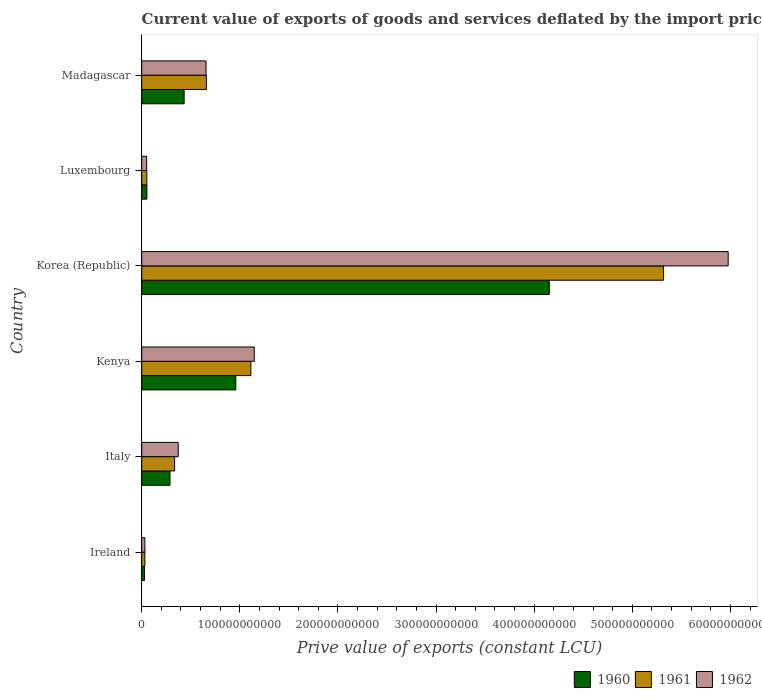Are the number of bars per tick equal to the number of legend labels?
Keep it short and to the point. Yes. How many bars are there on the 1st tick from the top?
Your response must be concise. 3. What is the label of the 1st group of bars from the top?
Provide a short and direct response. Madagascar. In how many cases, is the number of bars for a given country not equal to the number of legend labels?
Your answer should be very brief. 0. What is the prive value of exports in 1962 in Ireland?
Ensure brevity in your answer.  3.23e+09. Across all countries, what is the maximum prive value of exports in 1961?
Make the answer very short. 5.32e+11. Across all countries, what is the minimum prive value of exports in 1962?
Offer a very short reply. 3.23e+09. In which country was the prive value of exports in 1962 maximum?
Your response must be concise. Korea (Republic). In which country was the prive value of exports in 1962 minimum?
Offer a very short reply. Ireland. What is the total prive value of exports in 1960 in the graph?
Provide a short and direct response. 5.91e+11. What is the difference between the prive value of exports in 1960 in Ireland and that in Korea (Republic)?
Your response must be concise. -4.13e+11. What is the difference between the prive value of exports in 1960 in Italy and the prive value of exports in 1962 in Madagascar?
Ensure brevity in your answer.  -3.67e+1. What is the average prive value of exports in 1962 per country?
Make the answer very short. 1.37e+11. What is the difference between the prive value of exports in 1962 and prive value of exports in 1961 in Kenya?
Ensure brevity in your answer.  3.47e+09. What is the ratio of the prive value of exports in 1962 in Ireland to that in Italy?
Provide a short and direct response. 0.09. What is the difference between the highest and the second highest prive value of exports in 1960?
Keep it short and to the point. 3.19e+11. What is the difference between the highest and the lowest prive value of exports in 1961?
Provide a short and direct response. 5.29e+11. In how many countries, is the prive value of exports in 1961 greater than the average prive value of exports in 1961 taken over all countries?
Your answer should be very brief. 1. Is the sum of the prive value of exports in 1962 in Kenya and Luxembourg greater than the maximum prive value of exports in 1960 across all countries?
Ensure brevity in your answer.  No. What does the 2nd bar from the top in Ireland represents?
Keep it short and to the point. 1961. What does the 2nd bar from the bottom in Kenya represents?
Keep it short and to the point. 1961. How many countries are there in the graph?
Offer a terse response. 6. What is the difference between two consecutive major ticks on the X-axis?
Offer a terse response. 1.00e+11. Does the graph contain any zero values?
Provide a succinct answer. No. Where does the legend appear in the graph?
Ensure brevity in your answer.  Bottom right. How many legend labels are there?
Your answer should be compact. 3. What is the title of the graph?
Keep it short and to the point. Current value of exports of goods and services deflated by the import price index. Does "1979" appear as one of the legend labels in the graph?
Provide a succinct answer. No. What is the label or title of the X-axis?
Your response must be concise. Prive value of exports (constant LCU). What is the label or title of the Y-axis?
Your response must be concise. Country. What is the Prive value of exports (constant LCU) of 1960 in Ireland?
Keep it short and to the point. 2.78e+09. What is the Prive value of exports (constant LCU) of 1961 in Ireland?
Provide a short and direct response. 3.22e+09. What is the Prive value of exports (constant LCU) in 1962 in Ireland?
Your response must be concise. 3.23e+09. What is the Prive value of exports (constant LCU) of 1960 in Italy?
Give a very brief answer. 2.88e+1. What is the Prive value of exports (constant LCU) of 1961 in Italy?
Keep it short and to the point. 3.35e+1. What is the Prive value of exports (constant LCU) in 1962 in Italy?
Offer a very short reply. 3.72e+1. What is the Prive value of exports (constant LCU) of 1960 in Kenya?
Keep it short and to the point. 9.59e+1. What is the Prive value of exports (constant LCU) in 1961 in Kenya?
Keep it short and to the point. 1.11e+11. What is the Prive value of exports (constant LCU) of 1962 in Kenya?
Give a very brief answer. 1.15e+11. What is the Prive value of exports (constant LCU) of 1960 in Korea (Republic)?
Offer a terse response. 4.15e+11. What is the Prive value of exports (constant LCU) of 1961 in Korea (Republic)?
Offer a very short reply. 5.32e+11. What is the Prive value of exports (constant LCU) of 1962 in Korea (Republic)?
Make the answer very short. 5.98e+11. What is the Prive value of exports (constant LCU) of 1960 in Luxembourg?
Keep it short and to the point. 5.28e+09. What is the Prive value of exports (constant LCU) of 1961 in Luxembourg?
Keep it short and to the point. 5.22e+09. What is the Prive value of exports (constant LCU) of 1962 in Luxembourg?
Offer a very short reply. 5.02e+09. What is the Prive value of exports (constant LCU) of 1960 in Madagascar?
Keep it short and to the point. 4.32e+1. What is the Prive value of exports (constant LCU) in 1961 in Madagascar?
Your answer should be very brief. 6.59e+1. What is the Prive value of exports (constant LCU) of 1962 in Madagascar?
Offer a very short reply. 6.55e+1. Across all countries, what is the maximum Prive value of exports (constant LCU) of 1960?
Offer a terse response. 4.15e+11. Across all countries, what is the maximum Prive value of exports (constant LCU) in 1961?
Give a very brief answer. 5.32e+11. Across all countries, what is the maximum Prive value of exports (constant LCU) of 1962?
Provide a succinct answer. 5.98e+11. Across all countries, what is the minimum Prive value of exports (constant LCU) in 1960?
Your answer should be very brief. 2.78e+09. Across all countries, what is the minimum Prive value of exports (constant LCU) in 1961?
Provide a short and direct response. 3.22e+09. Across all countries, what is the minimum Prive value of exports (constant LCU) in 1962?
Your response must be concise. 3.23e+09. What is the total Prive value of exports (constant LCU) in 1960 in the graph?
Ensure brevity in your answer.  5.91e+11. What is the total Prive value of exports (constant LCU) of 1961 in the graph?
Provide a succinct answer. 7.51e+11. What is the total Prive value of exports (constant LCU) in 1962 in the graph?
Offer a very short reply. 8.23e+11. What is the difference between the Prive value of exports (constant LCU) in 1960 in Ireland and that in Italy?
Your answer should be very brief. -2.60e+1. What is the difference between the Prive value of exports (constant LCU) in 1961 in Ireland and that in Italy?
Make the answer very short. -3.03e+1. What is the difference between the Prive value of exports (constant LCU) of 1962 in Ireland and that in Italy?
Make the answer very short. -3.40e+1. What is the difference between the Prive value of exports (constant LCU) in 1960 in Ireland and that in Kenya?
Provide a succinct answer. -9.31e+1. What is the difference between the Prive value of exports (constant LCU) in 1961 in Ireland and that in Kenya?
Keep it short and to the point. -1.08e+11. What is the difference between the Prive value of exports (constant LCU) in 1962 in Ireland and that in Kenya?
Give a very brief answer. -1.11e+11. What is the difference between the Prive value of exports (constant LCU) of 1960 in Ireland and that in Korea (Republic)?
Provide a succinct answer. -4.13e+11. What is the difference between the Prive value of exports (constant LCU) in 1961 in Ireland and that in Korea (Republic)?
Your answer should be compact. -5.29e+11. What is the difference between the Prive value of exports (constant LCU) in 1962 in Ireland and that in Korea (Republic)?
Provide a short and direct response. -5.94e+11. What is the difference between the Prive value of exports (constant LCU) of 1960 in Ireland and that in Luxembourg?
Offer a very short reply. -2.50e+09. What is the difference between the Prive value of exports (constant LCU) of 1961 in Ireland and that in Luxembourg?
Keep it short and to the point. -2.01e+09. What is the difference between the Prive value of exports (constant LCU) of 1962 in Ireland and that in Luxembourg?
Ensure brevity in your answer.  -1.79e+09. What is the difference between the Prive value of exports (constant LCU) in 1960 in Ireland and that in Madagascar?
Offer a very short reply. -4.04e+1. What is the difference between the Prive value of exports (constant LCU) in 1961 in Ireland and that in Madagascar?
Provide a succinct answer. -6.27e+1. What is the difference between the Prive value of exports (constant LCU) of 1962 in Ireland and that in Madagascar?
Make the answer very short. -6.23e+1. What is the difference between the Prive value of exports (constant LCU) in 1960 in Italy and that in Kenya?
Keep it short and to the point. -6.71e+1. What is the difference between the Prive value of exports (constant LCU) of 1961 in Italy and that in Kenya?
Ensure brevity in your answer.  -7.77e+1. What is the difference between the Prive value of exports (constant LCU) of 1962 in Italy and that in Kenya?
Offer a terse response. -7.75e+1. What is the difference between the Prive value of exports (constant LCU) in 1960 in Italy and that in Korea (Republic)?
Offer a terse response. -3.87e+11. What is the difference between the Prive value of exports (constant LCU) in 1961 in Italy and that in Korea (Republic)?
Provide a short and direct response. -4.98e+11. What is the difference between the Prive value of exports (constant LCU) of 1962 in Italy and that in Korea (Republic)?
Keep it short and to the point. -5.60e+11. What is the difference between the Prive value of exports (constant LCU) of 1960 in Italy and that in Luxembourg?
Keep it short and to the point. 2.35e+1. What is the difference between the Prive value of exports (constant LCU) in 1961 in Italy and that in Luxembourg?
Ensure brevity in your answer.  2.83e+1. What is the difference between the Prive value of exports (constant LCU) of 1962 in Italy and that in Luxembourg?
Keep it short and to the point. 3.22e+1. What is the difference between the Prive value of exports (constant LCU) in 1960 in Italy and that in Madagascar?
Make the answer very short. -1.44e+1. What is the difference between the Prive value of exports (constant LCU) of 1961 in Italy and that in Madagascar?
Ensure brevity in your answer.  -3.24e+1. What is the difference between the Prive value of exports (constant LCU) in 1962 in Italy and that in Madagascar?
Provide a short and direct response. -2.84e+1. What is the difference between the Prive value of exports (constant LCU) in 1960 in Kenya and that in Korea (Republic)?
Give a very brief answer. -3.19e+11. What is the difference between the Prive value of exports (constant LCU) in 1961 in Kenya and that in Korea (Republic)?
Your answer should be compact. -4.21e+11. What is the difference between the Prive value of exports (constant LCU) in 1962 in Kenya and that in Korea (Republic)?
Your answer should be very brief. -4.83e+11. What is the difference between the Prive value of exports (constant LCU) of 1960 in Kenya and that in Luxembourg?
Provide a short and direct response. 9.06e+1. What is the difference between the Prive value of exports (constant LCU) of 1961 in Kenya and that in Luxembourg?
Your response must be concise. 1.06e+11. What is the difference between the Prive value of exports (constant LCU) in 1962 in Kenya and that in Luxembourg?
Make the answer very short. 1.10e+11. What is the difference between the Prive value of exports (constant LCU) of 1960 in Kenya and that in Madagascar?
Your answer should be compact. 5.27e+1. What is the difference between the Prive value of exports (constant LCU) in 1961 in Kenya and that in Madagascar?
Give a very brief answer. 4.53e+1. What is the difference between the Prive value of exports (constant LCU) of 1962 in Kenya and that in Madagascar?
Your response must be concise. 4.92e+1. What is the difference between the Prive value of exports (constant LCU) in 1960 in Korea (Republic) and that in Luxembourg?
Offer a terse response. 4.10e+11. What is the difference between the Prive value of exports (constant LCU) in 1961 in Korea (Republic) and that in Luxembourg?
Your answer should be very brief. 5.27e+11. What is the difference between the Prive value of exports (constant LCU) of 1962 in Korea (Republic) and that in Luxembourg?
Keep it short and to the point. 5.93e+11. What is the difference between the Prive value of exports (constant LCU) of 1960 in Korea (Republic) and that in Madagascar?
Your response must be concise. 3.72e+11. What is the difference between the Prive value of exports (constant LCU) of 1961 in Korea (Republic) and that in Madagascar?
Your answer should be very brief. 4.66e+11. What is the difference between the Prive value of exports (constant LCU) of 1962 in Korea (Republic) and that in Madagascar?
Offer a very short reply. 5.32e+11. What is the difference between the Prive value of exports (constant LCU) in 1960 in Luxembourg and that in Madagascar?
Give a very brief answer. -3.79e+1. What is the difference between the Prive value of exports (constant LCU) of 1961 in Luxembourg and that in Madagascar?
Your response must be concise. -6.07e+1. What is the difference between the Prive value of exports (constant LCU) in 1962 in Luxembourg and that in Madagascar?
Give a very brief answer. -6.05e+1. What is the difference between the Prive value of exports (constant LCU) of 1960 in Ireland and the Prive value of exports (constant LCU) of 1961 in Italy?
Your response must be concise. -3.08e+1. What is the difference between the Prive value of exports (constant LCU) in 1960 in Ireland and the Prive value of exports (constant LCU) in 1962 in Italy?
Your answer should be compact. -3.44e+1. What is the difference between the Prive value of exports (constant LCU) of 1961 in Ireland and the Prive value of exports (constant LCU) of 1962 in Italy?
Make the answer very short. -3.40e+1. What is the difference between the Prive value of exports (constant LCU) of 1960 in Ireland and the Prive value of exports (constant LCU) of 1961 in Kenya?
Keep it short and to the point. -1.08e+11. What is the difference between the Prive value of exports (constant LCU) of 1960 in Ireland and the Prive value of exports (constant LCU) of 1962 in Kenya?
Your answer should be compact. -1.12e+11. What is the difference between the Prive value of exports (constant LCU) of 1961 in Ireland and the Prive value of exports (constant LCU) of 1962 in Kenya?
Offer a terse response. -1.11e+11. What is the difference between the Prive value of exports (constant LCU) of 1960 in Ireland and the Prive value of exports (constant LCU) of 1961 in Korea (Republic)?
Ensure brevity in your answer.  -5.29e+11. What is the difference between the Prive value of exports (constant LCU) in 1960 in Ireland and the Prive value of exports (constant LCU) in 1962 in Korea (Republic)?
Your answer should be very brief. -5.95e+11. What is the difference between the Prive value of exports (constant LCU) in 1961 in Ireland and the Prive value of exports (constant LCU) in 1962 in Korea (Republic)?
Offer a terse response. -5.94e+11. What is the difference between the Prive value of exports (constant LCU) of 1960 in Ireland and the Prive value of exports (constant LCU) of 1961 in Luxembourg?
Offer a terse response. -2.45e+09. What is the difference between the Prive value of exports (constant LCU) in 1960 in Ireland and the Prive value of exports (constant LCU) in 1962 in Luxembourg?
Ensure brevity in your answer.  -2.24e+09. What is the difference between the Prive value of exports (constant LCU) in 1961 in Ireland and the Prive value of exports (constant LCU) in 1962 in Luxembourg?
Keep it short and to the point. -1.80e+09. What is the difference between the Prive value of exports (constant LCU) of 1960 in Ireland and the Prive value of exports (constant LCU) of 1961 in Madagascar?
Your response must be concise. -6.31e+1. What is the difference between the Prive value of exports (constant LCU) in 1960 in Ireland and the Prive value of exports (constant LCU) in 1962 in Madagascar?
Keep it short and to the point. -6.28e+1. What is the difference between the Prive value of exports (constant LCU) in 1961 in Ireland and the Prive value of exports (constant LCU) in 1962 in Madagascar?
Your answer should be compact. -6.23e+1. What is the difference between the Prive value of exports (constant LCU) of 1960 in Italy and the Prive value of exports (constant LCU) of 1961 in Kenya?
Your answer should be very brief. -8.24e+1. What is the difference between the Prive value of exports (constant LCU) in 1960 in Italy and the Prive value of exports (constant LCU) in 1962 in Kenya?
Provide a succinct answer. -8.59e+1. What is the difference between the Prive value of exports (constant LCU) in 1961 in Italy and the Prive value of exports (constant LCU) in 1962 in Kenya?
Keep it short and to the point. -8.12e+1. What is the difference between the Prive value of exports (constant LCU) of 1960 in Italy and the Prive value of exports (constant LCU) of 1961 in Korea (Republic)?
Offer a very short reply. -5.03e+11. What is the difference between the Prive value of exports (constant LCU) in 1960 in Italy and the Prive value of exports (constant LCU) in 1962 in Korea (Republic)?
Your response must be concise. -5.69e+11. What is the difference between the Prive value of exports (constant LCU) of 1961 in Italy and the Prive value of exports (constant LCU) of 1962 in Korea (Republic)?
Your answer should be compact. -5.64e+11. What is the difference between the Prive value of exports (constant LCU) in 1960 in Italy and the Prive value of exports (constant LCU) in 1961 in Luxembourg?
Make the answer very short. 2.36e+1. What is the difference between the Prive value of exports (constant LCU) of 1960 in Italy and the Prive value of exports (constant LCU) of 1962 in Luxembourg?
Ensure brevity in your answer.  2.38e+1. What is the difference between the Prive value of exports (constant LCU) in 1961 in Italy and the Prive value of exports (constant LCU) in 1962 in Luxembourg?
Keep it short and to the point. 2.85e+1. What is the difference between the Prive value of exports (constant LCU) in 1960 in Italy and the Prive value of exports (constant LCU) in 1961 in Madagascar?
Your answer should be very brief. -3.71e+1. What is the difference between the Prive value of exports (constant LCU) of 1960 in Italy and the Prive value of exports (constant LCU) of 1962 in Madagascar?
Ensure brevity in your answer.  -3.67e+1. What is the difference between the Prive value of exports (constant LCU) of 1961 in Italy and the Prive value of exports (constant LCU) of 1962 in Madagascar?
Your answer should be very brief. -3.20e+1. What is the difference between the Prive value of exports (constant LCU) of 1960 in Kenya and the Prive value of exports (constant LCU) of 1961 in Korea (Republic)?
Ensure brevity in your answer.  -4.36e+11. What is the difference between the Prive value of exports (constant LCU) in 1960 in Kenya and the Prive value of exports (constant LCU) in 1962 in Korea (Republic)?
Your response must be concise. -5.02e+11. What is the difference between the Prive value of exports (constant LCU) in 1961 in Kenya and the Prive value of exports (constant LCU) in 1962 in Korea (Republic)?
Your answer should be compact. -4.86e+11. What is the difference between the Prive value of exports (constant LCU) in 1960 in Kenya and the Prive value of exports (constant LCU) in 1961 in Luxembourg?
Offer a very short reply. 9.07e+1. What is the difference between the Prive value of exports (constant LCU) of 1960 in Kenya and the Prive value of exports (constant LCU) of 1962 in Luxembourg?
Provide a succinct answer. 9.09e+1. What is the difference between the Prive value of exports (constant LCU) of 1961 in Kenya and the Prive value of exports (constant LCU) of 1962 in Luxembourg?
Provide a short and direct response. 1.06e+11. What is the difference between the Prive value of exports (constant LCU) in 1960 in Kenya and the Prive value of exports (constant LCU) in 1961 in Madagascar?
Your answer should be very brief. 3.00e+1. What is the difference between the Prive value of exports (constant LCU) in 1960 in Kenya and the Prive value of exports (constant LCU) in 1962 in Madagascar?
Give a very brief answer. 3.03e+1. What is the difference between the Prive value of exports (constant LCU) of 1961 in Kenya and the Prive value of exports (constant LCU) of 1962 in Madagascar?
Your answer should be compact. 4.57e+1. What is the difference between the Prive value of exports (constant LCU) of 1960 in Korea (Republic) and the Prive value of exports (constant LCU) of 1961 in Luxembourg?
Give a very brief answer. 4.10e+11. What is the difference between the Prive value of exports (constant LCU) of 1960 in Korea (Republic) and the Prive value of exports (constant LCU) of 1962 in Luxembourg?
Give a very brief answer. 4.10e+11. What is the difference between the Prive value of exports (constant LCU) in 1961 in Korea (Republic) and the Prive value of exports (constant LCU) in 1962 in Luxembourg?
Offer a very short reply. 5.27e+11. What is the difference between the Prive value of exports (constant LCU) in 1960 in Korea (Republic) and the Prive value of exports (constant LCU) in 1961 in Madagascar?
Give a very brief answer. 3.49e+11. What is the difference between the Prive value of exports (constant LCU) in 1960 in Korea (Republic) and the Prive value of exports (constant LCU) in 1962 in Madagascar?
Offer a very short reply. 3.50e+11. What is the difference between the Prive value of exports (constant LCU) of 1961 in Korea (Republic) and the Prive value of exports (constant LCU) of 1962 in Madagascar?
Your response must be concise. 4.66e+11. What is the difference between the Prive value of exports (constant LCU) of 1960 in Luxembourg and the Prive value of exports (constant LCU) of 1961 in Madagascar?
Ensure brevity in your answer.  -6.06e+1. What is the difference between the Prive value of exports (constant LCU) of 1960 in Luxembourg and the Prive value of exports (constant LCU) of 1962 in Madagascar?
Provide a succinct answer. -6.03e+1. What is the difference between the Prive value of exports (constant LCU) in 1961 in Luxembourg and the Prive value of exports (constant LCU) in 1962 in Madagascar?
Provide a succinct answer. -6.03e+1. What is the average Prive value of exports (constant LCU) in 1960 per country?
Ensure brevity in your answer.  9.86e+1. What is the average Prive value of exports (constant LCU) in 1961 per country?
Offer a very short reply. 1.25e+11. What is the average Prive value of exports (constant LCU) of 1962 per country?
Offer a terse response. 1.37e+11. What is the difference between the Prive value of exports (constant LCU) of 1960 and Prive value of exports (constant LCU) of 1961 in Ireland?
Provide a short and direct response. -4.39e+08. What is the difference between the Prive value of exports (constant LCU) of 1960 and Prive value of exports (constant LCU) of 1962 in Ireland?
Your response must be concise. -4.49e+08. What is the difference between the Prive value of exports (constant LCU) of 1961 and Prive value of exports (constant LCU) of 1962 in Ireland?
Provide a succinct answer. -9.94e+06. What is the difference between the Prive value of exports (constant LCU) of 1960 and Prive value of exports (constant LCU) of 1961 in Italy?
Your answer should be very brief. -4.73e+09. What is the difference between the Prive value of exports (constant LCU) of 1960 and Prive value of exports (constant LCU) of 1962 in Italy?
Your answer should be compact. -8.38e+09. What is the difference between the Prive value of exports (constant LCU) in 1961 and Prive value of exports (constant LCU) in 1962 in Italy?
Offer a terse response. -3.65e+09. What is the difference between the Prive value of exports (constant LCU) of 1960 and Prive value of exports (constant LCU) of 1961 in Kenya?
Offer a very short reply. -1.54e+1. What is the difference between the Prive value of exports (constant LCU) of 1960 and Prive value of exports (constant LCU) of 1962 in Kenya?
Your answer should be compact. -1.88e+1. What is the difference between the Prive value of exports (constant LCU) of 1961 and Prive value of exports (constant LCU) of 1962 in Kenya?
Offer a very short reply. -3.47e+09. What is the difference between the Prive value of exports (constant LCU) of 1960 and Prive value of exports (constant LCU) of 1961 in Korea (Republic)?
Provide a succinct answer. -1.16e+11. What is the difference between the Prive value of exports (constant LCU) of 1960 and Prive value of exports (constant LCU) of 1962 in Korea (Republic)?
Your answer should be compact. -1.82e+11. What is the difference between the Prive value of exports (constant LCU) of 1961 and Prive value of exports (constant LCU) of 1962 in Korea (Republic)?
Offer a very short reply. -6.59e+1. What is the difference between the Prive value of exports (constant LCU) in 1960 and Prive value of exports (constant LCU) in 1961 in Luxembourg?
Offer a very short reply. 5.55e+07. What is the difference between the Prive value of exports (constant LCU) in 1960 and Prive value of exports (constant LCU) in 1962 in Luxembourg?
Make the answer very short. 2.64e+08. What is the difference between the Prive value of exports (constant LCU) of 1961 and Prive value of exports (constant LCU) of 1962 in Luxembourg?
Your answer should be very brief. 2.08e+08. What is the difference between the Prive value of exports (constant LCU) of 1960 and Prive value of exports (constant LCU) of 1961 in Madagascar?
Your response must be concise. -2.27e+1. What is the difference between the Prive value of exports (constant LCU) in 1960 and Prive value of exports (constant LCU) in 1962 in Madagascar?
Your answer should be compact. -2.23e+1. What is the difference between the Prive value of exports (constant LCU) of 1961 and Prive value of exports (constant LCU) of 1962 in Madagascar?
Offer a terse response. 3.52e+08. What is the ratio of the Prive value of exports (constant LCU) in 1960 in Ireland to that in Italy?
Provide a succinct answer. 0.1. What is the ratio of the Prive value of exports (constant LCU) of 1961 in Ireland to that in Italy?
Give a very brief answer. 0.1. What is the ratio of the Prive value of exports (constant LCU) of 1962 in Ireland to that in Italy?
Keep it short and to the point. 0.09. What is the ratio of the Prive value of exports (constant LCU) in 1960 in Ireland to that in Kenya?
Offer a very short reply. 0.03. What is the ratio of the Prive value of exports (constant LCU) of 1961 in Ireland to that in Kenya?
Offer a very short reply. 0.03. What is the ratio of the Prive value of exports (constant LCU) in 1962 in Ireland to that in Kenya?
Your answer should be compact. 0.03. What is the ratio of the Prive value of exports (constant LCU) of 1960 in Ireland to that in Korea (Republic)?
Ensure brevity in your answer.  0.01. What is the ratio of the Prive value of exports (constant LCU) of 1961 in Ireland to that in Korea (Republic)?
Provide a short and direct response. 0.01. What is the ratio of the Prive value of exports (constant LCU) in 1962 in Ireland to that in Korea (Republic)?
Your answer should be compact. 0.01. What is the ratio of the Prive value of exports (constant LCU) in 1960 in Ireland to that in Luxembourg?
Make the answer very short. 0.53. What is the ratio of the Prive value of exports (constant LCU) of 1961 in Ireland to that in Luxembourg?
Keep it short and to the point. 0.62. What is the ratio of the Prive value of exports (constant LCU) of 1962 in Ireland to that in Luxembourg?
Keep it short and to the point. 0.64. What is the ratio of the Prive value of exports (constant LCU) of 1960 in Ireland to that in Madagascar?
Provide a short and direct response. 0.06. What is the ratio of the Prive value of exports (constant LCU) of 1961 in Ireland to that in Madagascar?
Keep it short and to the point. 0.05. What is the ratio of the Prive value of exports (constant LCU) of 1962 in Ireland to that in Madagascar?
Your answer should be very brief. 0.05. What is the ratio of the Prive value of exports (constant LCU) of 1960 in Italy to that in Kenya?
Ensure brevity in your answer.  0.3. What is the ratio of the Prive value of exports (constant LCU) in 1961 in Italy to that in Kenya?
Provide a short and direct response. 0.3. What is the ratio of the Prive value of exports (constant LCU) of 1962 in Italy to that in Kenya?
Provide a succinct answer. 0.32. What is the ratio of the Prive value of exports (constant LCU) in 1960 in Italy to that in Korea (Republic)?
Give a very brief answer. 0.07. What is the ratio of the Prive value of exports (constant LCU) of 1961 in Italy to that in Korea (Republic)?
Give a very brief answer. 0.06. What is the ratio of the Prive value of exports (constant LCU) of 1962 in Italy to that in Korea (Republic)?
Your response must be concise. 0.06. What is the ratio of the Prive value of exports (constant LCU) in 1960 in Italy to that in Luxembourg?
Give a very brief answer. 5.46. What is the ratio of the Prive value of exports (constant LCU) in 1961 in Italy to that in Luxembourg?
Your response must be concise. 6.42. What is the ratio of the Prive value of exports (constant LCU) of 1962 in Italy to that in Luxembourg?
Ensure brevity in your answer.  7.42. What is the ratio of the Prive value of exports (constant LCU) of 1960 in Italy to that in Madagascar?
Offer a very short reply. 0.67. What is the ratio of the Prive value of exports (constant LCU) in 1961 in Italy to that in Madagascar?
Make the answer very short. 0.51. What is the ratio of the Prive value of exports (constant LCU) of 1962 in Italy to that in Madagascar?
Ensure brevity in your answer.  0.57. What is the ratio of the Prive value of exports (constant LCU) of 1960 in Kenya to that in Korea (Republic)?
Provide a succinct answer. 0.23. What is the ratio of the Prive value of exports (constant LCU) of 1961 in Kenya to that in Korea (Republic)?
Keep it short and to the point. 0.21. What is the ratio of the Prive value of exports (constant LCU) of 1962 in Kenya to that in Korea (Republic)?
Make the answer very short. 0.19. What is the ratio of the Prive value of exports (constant LCU) in 1960 in Kenya to that in Luxembourg?
Provide a short and direct response. 18.16. What is the ratio of the Prive value of exports (constant LCU) of 1961 in Kenya to that in Luxembourg?
Provide a succinct answer. 21.29. What is the ratio of the Prive value of exports (constant LCU) of 1962 in Kenya to that in Luxembourg?
Provide a short and direct response. 22.87. What is the ratio of the Prive value of exports (constant LCU) in 1960 in Kenya to that in Madagascar?
Your answer should be compact. 2.22. What is the ratio of the Prive value of exports (constant LCU) in 1961 in Kenya to that in Madagascar?
Your response must be concise. 1.69. What is the ratio of the Prive value of exports (constant LCU) in 1962 in Kenya to that in Madagascar?
Provide a short and direct response. 1.75. What is the ratio of the Prive value of exports (constant LCU) in 1960 in Korea (Republic) to that in Luxembourg?
Provide a short and direct response. 78.67. What is the ratio of the Prive value of exports (constant LCU) of 1961 in Korea (Republic) to that in Luxembourg?
Your answer should be very brief. 101.79. What is the ratio of the Prive value of exports (constant LCU) of 1962 in Korea (Republic) to that in Luxembourg?
Your answer should be very brief. 119.15. What is the ratio of the Prive value of exports (constant LCU) of 1960 in Korea (Republic) to that in Madagascar?
Your response must be concise. 9.61. What is the ratio of the Prive value of exports (constant LCU) of 1961 in Korea (Republic) to that in Madagascar?
Keep it short and to the point. 8.07. What is the ratio of the Prive value of exports (constant LCU) in 1962 in Korea (Republic) to that in Madagascar?
Give a very brief answer. 9.12. What is the ratio of the Prive value of exports (constant LCU) of 1960 in Luxembourg to that in Madagascar?
Ensure brevity in your answer.  0.12. What is the ratio of the Prive value of exports (constant LCU) of 1961 in Luxembourg to that in Madagascar?
Ensure brevity in your answer.  0.08. What is the ratio of the Prive value of exports (constant LCU) of 1962 in Luxembourg to that in Madagascar?
Give a very brief answer. 0.08. What is the difference between the highest and the second highest Prive value of exports (constant LCU) in 1960?
Your answer should be very brief. 3.19e+11. What is the difference between the highest and the second highest Prive value of exports (constant LCU) in 1961?
Your answer should be compact. 4.21e+11. What is the difference between the highest and the second highest Prive value of exports (constant LCU) in 1962?
Your answer should be compact. 4.83e+11. What is the difference between the highest and the lowest Prive value of exports (constant LCU) of 1960?
Offer a terse response. 4.13e+11. What is the difference between the highest and the lowest Prive value of exports (constant LCU) in 1961?
Your answer should be very brief. 5.29e+11. What is the difference between the highest and the lowest Prive value of exports (constant LCU) in 1962?
Make the answer very short. 5.94e+11. 